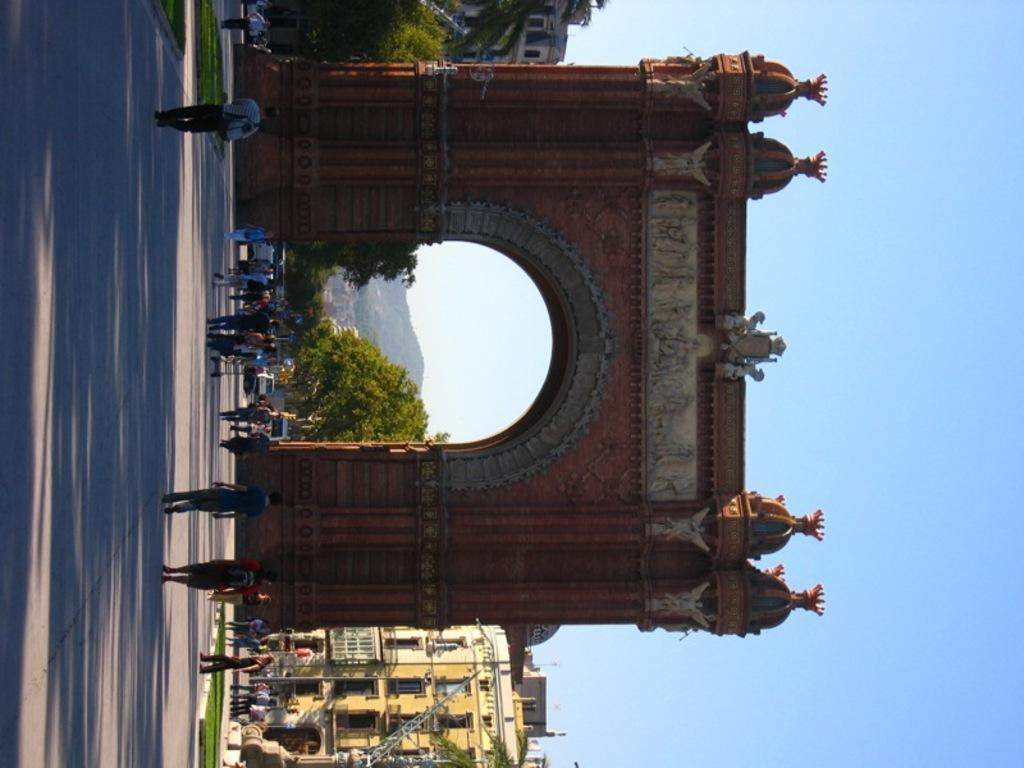What type of structure is present in the image? There is an arch in the image. Who or what can be seen in the image? There are people in the image. What can be seen in the background of the image? There are trees, buildings, hills, and the sky visible in the background of the image. On which side of the image is the road located? The road is on the left side of the image. What is the taste of the dog in the image? There is no dog present in the image, so it is not possible to determine its taste. 